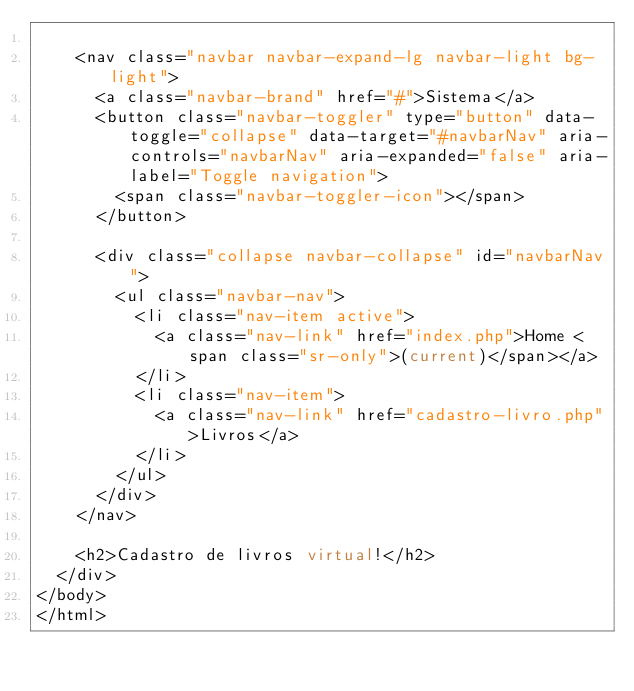<code> <loc_0><loc_0><loc_500><loc_500><_PHP_>
    <nav class="navbar navbar-expand-lg navbar-light bg-light">
      <a class="navbar-brand" href="#">Sistema</a>
      <button class="navbar-toggler" type="button" data-toggle="collapse" data-target="#navbarNav" aria-controls="navbarNav" aria-expanded="false" aria-label="Toggle navigation">
        <span class="navbar-toggler-icon"></span>
      </button>

      <div class="collapse navbar-collapse" id="navbarNav">
        <ul class="navbar-nav">
          <li class="nav-item active">
            <a class="nav-link" href="index.php">Home <span class="sr-only">(current)</span></a>
          </li>
          <li class="nav-item">
            <a class="nav-link" href="cadastro-livro.php">Livros</a>
          </li>
        </ul>
      </div>
    </nav>

    <h2>Cadastro de livros virtual!</h2>
  </div>
</body>
</html>
</code> 